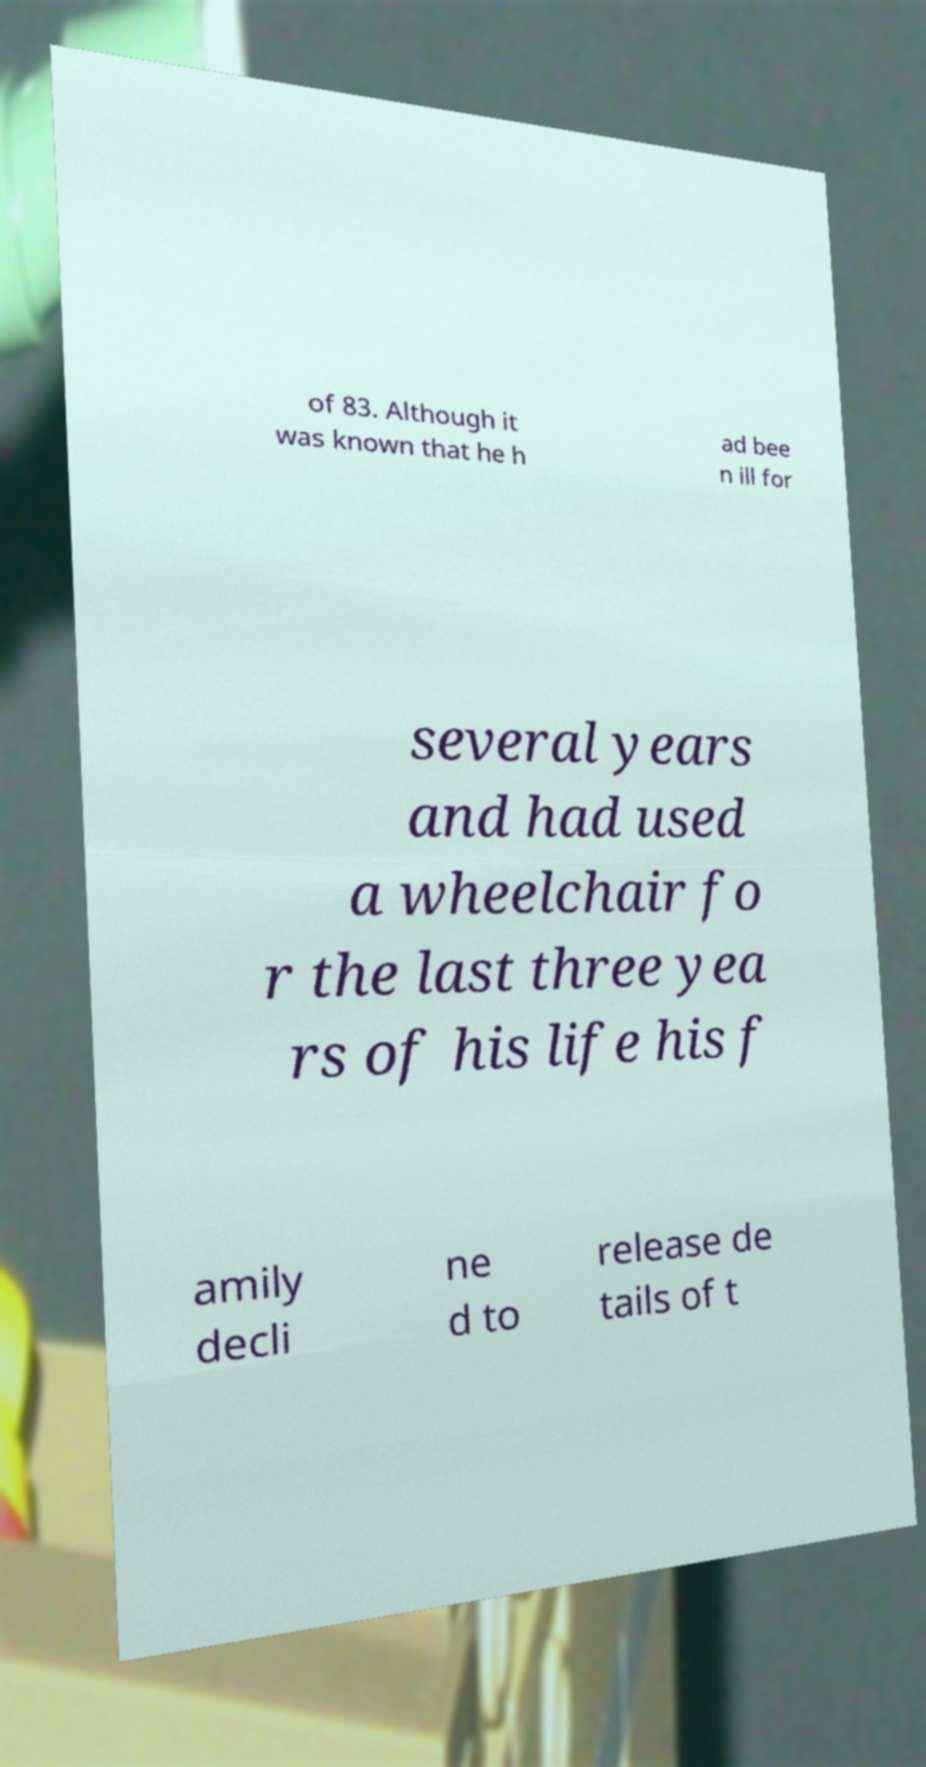Please identify and transcribe the text found in this image. of 83. Although it was known that he h ad bee n ill for several years and had used a wheelchair fo r the last three yea rs of his life his f amily decli ne d to release de tails of t 